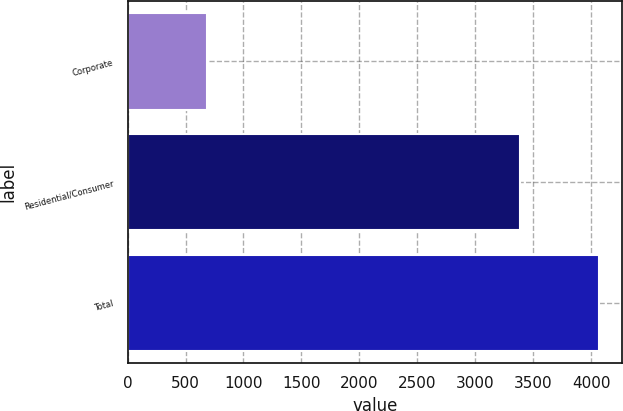<chart> <loc_0><loc_0><loc_500><loc_500><bar_chart><fcel>Corporate<fcel>Residential/Consumer<fcel>Total<nl><fcel>682<fcel>3383<fcel>4065<nl></chart> 